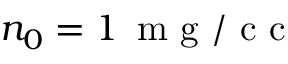Convert formula to latex. <formula><loc_0><loc_0><loc_500><loc_500>n _ { 0 } = 1 \, m g / c c</formula> 